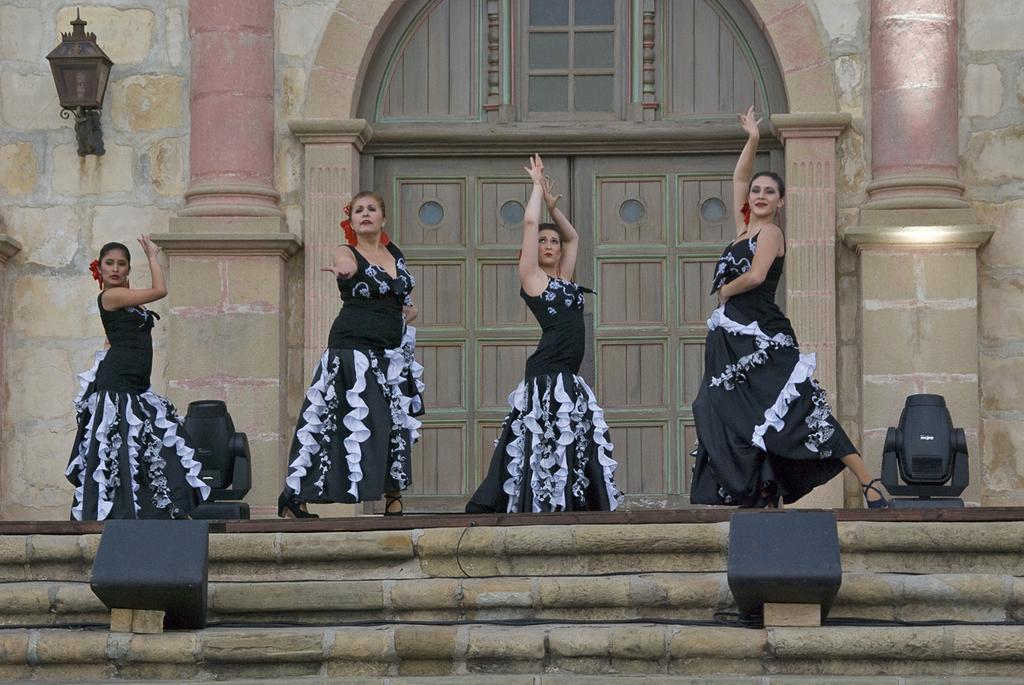Can you describe this image briefly? In this picture we can see a few women are dancing in front of the building. There are loud speakers on the path and on the stairs. We can see an arch on the building. There is a lantern on the wall. We can see a few pillars. 